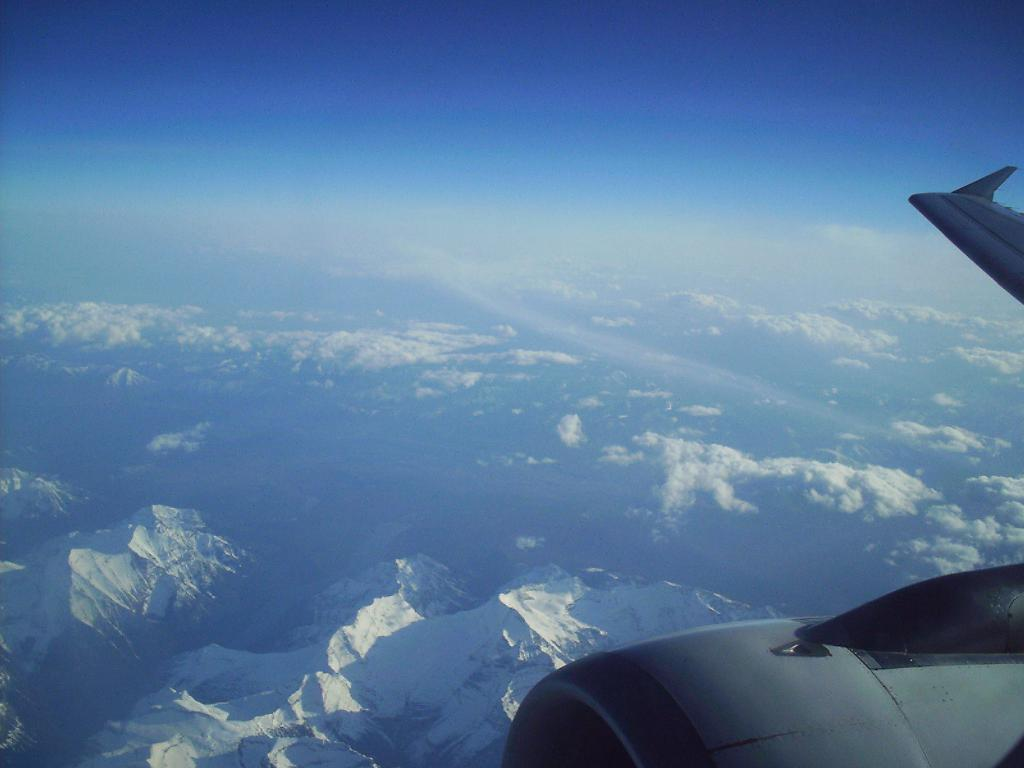What is the main subject of the image? The main subject of the image is an airplane. What can be seen in the background of the image? There are clouds in the sky and mountains visible in the background of the image. What type of insect can be seen learning to fly in the image? There is no insect present in the image, and therefore no learning to fly can be observed. 